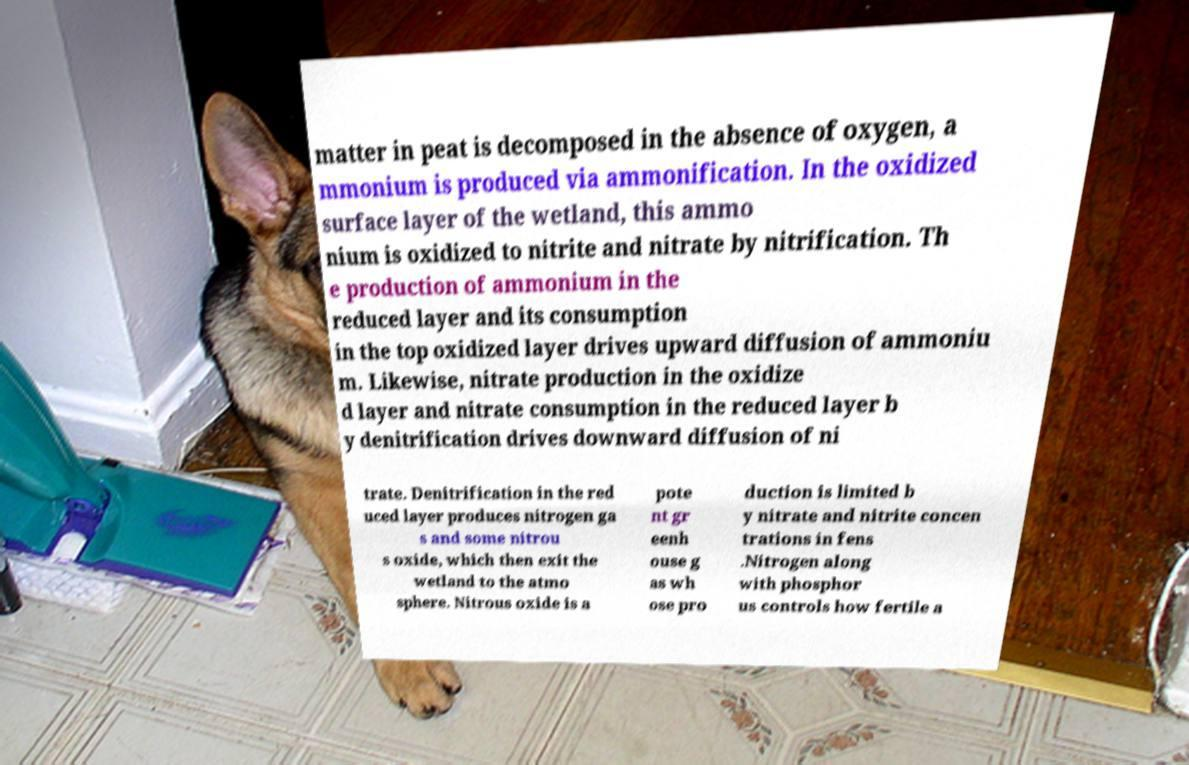I need the written content from this picture converted into text. Can you do that? matter in peat is decomposed in the absence of oxygen, a mmonium is produced via ammonification. In the oxidized surface layer of the wetland, this ammo nium is oxidized to nitrite and nitrate by nitrification. Th e production of ammonium in the reduced layer and its consumption in the top oxidized layer drives upward diffusion of ammoniu m. Likewise, nitrate production in the oxidize d layer and nitrate consumption in the reduced layer b y denitrification drives downward diffusion of ni trate. Denitrification in the red uced layer produces nitrogen ga s and some nitrou s oxide, which then exit the wetland to the atmo sphere. Nitrous oxide is a pote nt gr eenh ouse g as wh ose pro duction is limited b y nitrate and nitrite concen trations in fens .Nitrogen along with phosphor us controls how fertile a 